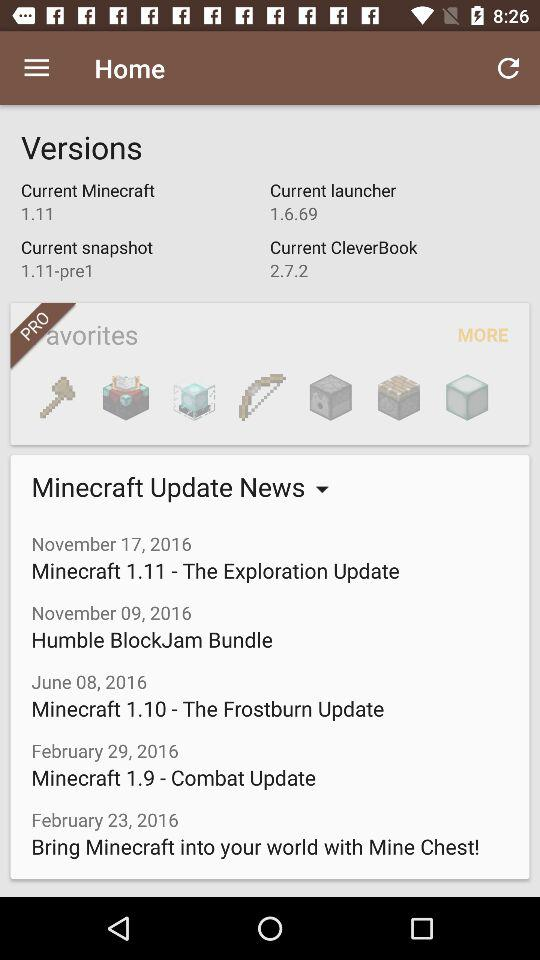What is the current version of "Minecraft"? The current version is 1.11. 